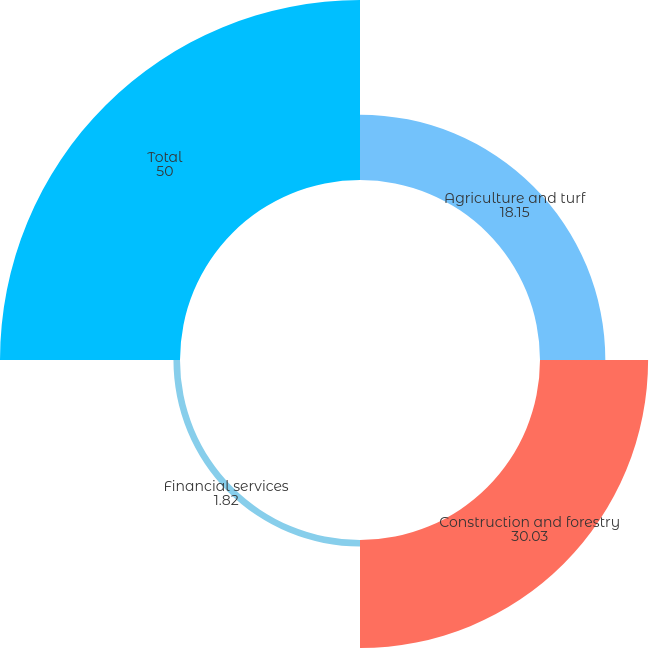Convert chart to OTSL. <chart><loc_0><loc_0><loc_500><loc_500><pie_chart><fcel>Agriculture and turf<fcel>Construction and forestry<fcel>Financial services<fcel>Total<nl><fcel>18.15%<fcel>30.03%<fcel>1.82%<fcel>50.0%<nl></chart> 